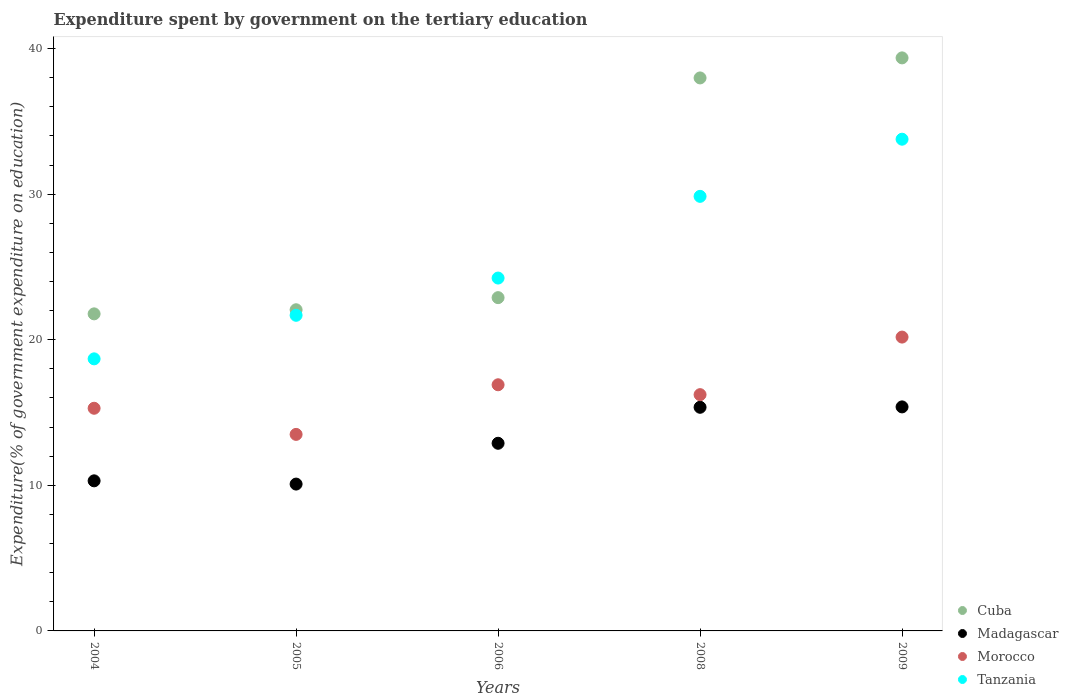How many different coloured dotlines are there?
Offer a very short reply. 4. Is the number of dotlines equal to the number of legend labels?
Ensure brevity in your answer.  Yes. What is the expenditure spent by government on the tertiary education in Morocco in 2005?
Keep it short and to the point. 13.5. Across all years, what is the maximum expenditure spent by government on the tertiary education in Tanzania?
Provide a short and direct response. 33.78. Across all years, what is the minimum expenditure spent by government on the tertiary education in Morocco?
Your response must be concise. 13.5. In which year was the expenditure spent by government on the tertiary education in Madagascar maximum?
Offer a terse response. 2009. What is the total expenditure spent by government on the tertiary education in Madagascar in the graph?
Keep it short and to the point. 64.03. What is the difference between the expenditure spent by government on the tertiary education in Cuba in 2004 and that in 2008?
Provide a short and direct response. -16.21. What is the difference between the expenditure spent by government on the tertiary education in Tanzania in 2004 and the expenditure spent by government on the tertiary education in Morocco in 2009?
Your answer should be very brief. -1.5. What is the average expenditure spent by government on the tertiary education in Madagascar per year?
Make the answer very short. 12.81. In the year 2005, what is the difference between the expenditure spent by government on the tertiary education in Madagascar and expenditure spent by government on the tertiary education in Tanzania?
Your answer should be very brief. -11.59. What is the ratio of the expenditure spent by government on the tertiary education in Tanzania in 2004 to that in 2006?
Provide a succinct answer. 0.77. Is the expenditure spent by government on the tertiary education in Tanzania in 2005 less than that in 2006?
Provide a short and direct response. Yes. Is the difference between the expenditure spent by government on the tertiary education in Madagascar in 2008 and 2009 greater than the difference between the expenditure spent by government on the tertiary education in Tanzania in 2008 and 2009?
Offer a very short reply. Yes. What is the difference between the highest and the second highest expenditure spent by government on the tertiary education in Tanzania?
Provide a short and direct response. 3.93. What is the difference between the highest and the lowest expenditure spent by government on the tertiary education in Tanzania?
Give a very brief answer. 15.09. Is the sum of the expenditure spent by government on the tertiary education in Madagascar in 2005 and 2009 greater than the maximum expenditure spent by government on the tertiary education in Tanzania across all years?
Provide a succinct answer. No. Is it the case that in every year, the sum of the expenditure spent by government on the tertiary education in Morocco and expenditure spent by government on the tertiary education in Tanzania  is greater than the sum of expenditure spent by government on the tertiary education in Cuba and expenditure spent by government on the tertiary education in Madagascar?
Make the answer very short. No. Is the expenditure spent by government on the tertiary education in Madagascar strictly greater than the expenditure spent by government on the tertiary education in Tanzania over the years?
Give a very brief answer. No. Is the expenditure spent by government on the tertiary education in Cuba strictly less than the expenditure spent by government on the tertiary education in Morocco over the years?
Your answer should be very brief. No. How many dotlines are there?
Ensure brevity in your answer.  4. How many years are there in the graph?
Your response must be concise. 5. What is the difference between two consecutive major ticks on the Y-axis?
Keep it short and to the point. 10. Does the graph contain grids?
Ensure brevity in your answer.  No. Where does the legend appear in the graph?
Your response must be concise. Bottom right. How are the legend labels stacked?
Your answer should be compact. Vertical. What is the title of the graph?
Make the answer very short. Expenditure spent by government on the tertiary education. What is the label or title of the Y-axis?
Keep it short and to the point. Expenditure(% of government expenditure on education). What is the Expenditure(% of government expenditure on education) in Cuba in 2004?
Your response must be concise. 21.78. What is the Expenditure(% of government expenditure on education) of Madagascar in 2004?
Your answer should be very brief. 10.31. What is the Expenditure(% of government expenditure on education) in Morocco in 2004?
Offer a very short reply. 15.29. What is the Expenditure(% of government expenditure on education) in Tanzania in 2004?
Ensure brevity in your answer.  18.69. What is the Expenditure(% of government expenditure on education) in Cuba in 2005?
Keep it short and to the point. 22.06. What is the Expenditure(% of government expenditure on education) of Madagascar in 2005?
Your response must be concise. 10.09. What is the Expenditure(% of government expenditure on education) in Morocco in 2005?
Offer a terse response. 13.5. What is the Expenditure(% of government expenditure on education) of Tanzania in 2005?
Your response must be concise. 21.68. What is the Expenditure(% of government expenditure on education) in Cuba in 2006?
Ensure brevity in your answer.  22.89. What is the Expenditure(% of government expenditure on education) of Madagascar in 2006?
Your answer should be very brief. 12.89. What is the Expenditure(% of government expenditure on education) of Morocco in 2006?
Your response must be concise. 16.91. What is the Expenditure(% of government expenditure on education) in Tanzania in 2006?
Give a very brief answer. 24.24. What is the Expenditure(% of government expenditure on education) of Cuba in 2008?
Your response must be concise. 37.98. What is the Expenditure(% of government expenditure on education) of Madagascar in 2008?
Your response must be concise. 15.36. What is the Expenditure(% of government expenditure on education) in Morocco in 2008?
Provide a short and direct response. 16.23. What is the Expenditure(% of government expenditure on education) of Tanzania in 2008?
Provide a short and direct response. 29.85. What is the Expenditure(% of government expenditure on education) in Cuba in 2009?
Your response must be concise. 39.36. What is the Expenditure(% of government expenditure on education) of Madagascar in 2009?
Your answer should be compact. 15.39. What is the Expenditure(% of government expenditure on education) of Morocco in 2009?
Offer a terse response. 20.18. What is the Expenditure(% of government expenditure on education) of Tanzania in 2009?
Make the answer very short. 33.78. Across all years, what is the maximum Expenditure(% of government expenditure on education) of Cuba?
Give a very brief answer. 39.36. Across all years, what is the maximum Expenditure(% of government expenditure on education) of Madagascar?
Provide a short and direct response. 15.39. Across all years, what is the maximum Expenditure(% of government expenditure on education) of Morocco?
Provide a short and direct response. 20.18. Across all years, what is the maximum Expenditure(% of government expenditure on education) in Tanzania?
Give a very brief answer. 33.78. Across all years, what is the minimum Expenditure(% of government expenditure on education) in Cuba?
Provide a succinct answer. 21.78. Across all years, what is the minimum Expenditure(% of government expenditure on education) of Madagascar?
Offer a very short reply. 10.09. Across all years, what is the minimum Expenditure(% of government expenditure on education) in Morocco?
Provide a short and direct response. 13.5. Across all years, what is the minimum Expenditure(% of government expenditure on education) in Tanzania?
Your response must be concise. 18.69. What is the total Expenditure(% of government expenditure on education) of Cuba in the graph?
Provide a succinct answer. 144.08. What is the total Expenditure(% of government expenditure on education) in Madagascar in the graph?
Your response must be concise. 64.03. What is the total Expenditure(% of government expenditure on education) of Morocco in the graph?
Provide a succinct answer. 82.11. What is the total Expenditure(% of government expenditure on education) of Tanzania in the graph?
Keep it short and to the point. 128.23. What is the difference between the Expenditure(% of government expenditure on education) in Cuba in 2004 and that in 2005?
Your answer should be compact. -0.28. What is the difference between the Expenditure(% of government expenditure on education) in Madagascar in 2004 and that in 2005?
Ensure brevity in your answer.  0.22. What is the difference between the Expenditure(% of government expenditure on education) in Morocco in 2004 and that in 2005?
Keep it short and to the point. 1.79. What is the difference between the Expenditure(% of government expenditure on education) of Tanzania in 2004 and that in 2005?
Give a very brief answer. -2.99. What is the difference between the Expenditure(% of government expenditure on education) of Cuba in 2004 and that in 2006?
Your answer should be compact. -1.11. What is the difference between the Expenditure(% of government expenditure on education) in Madagascar in 2004 and that in 2006?
Make the answer very short. -2.58. What is the difference between the Expenditure(% of government expenditure on education) in Morocco in 2004 and that in 2006?
Give a very brief answer. -1.61. What is the difference between the Expenditure(% of government expenditure on education) of Tanzania in 2004 and that in 2006?
Offer a terse response. -5.55. What is the difference between the Expenditure(% of government expenditure on education) of Cuba in 2004 and that in 2008?
Offer a terse response. -16.21. What is the difference between the Expenditure(% of government expenditure on education) of Madagascar in 2004 and that in 2008?
Your response must be concise. -5.05. What is the difference between the Expenditure(% of government expenditure on education) of Morocco in 2004 and that in 2008?
Offer a terse response. -0.94. What is the difference between the Expenditure(% of government expenditure on education) in Tanzania in 2004 and that in 2008?
Offer a terse response. -11.16. What is the difference between the Expenditure(% of government expenditure on education) in Cuba in 2004 and that in 2009?
Ensure brevity in your answer.  -17.58. What is the difference between the Expenditure(% of government expenditure on education) of Madagascar in 2004 and that in 2009?
Ensure brevity in your answer.  -5.08. What is the difference between the Expenditure(% of government expenditure on education) of Morocco in 2004 and that in 2009?
Give a very brief answer. -4.89. What is the difference between the Expenditure(% of government expenditure on education) in Tanzania in 2004 and that in 2009?
Provide a short and direct response. -15.09. What is the difference between the Expenditure(% of government expenditure on education) in Cuba in 2005 and that in 2006?
Offer a very short reply. -0.83. What is the difference between the Expenditure(% of government expenditure on education) in Madagascar in 2005 and that in 2006?
Provide a short and direct response. -2.8. What is the difference between the Expenditure(% of government expenditure on education) in Morocco in 2005 and that in 2006?
Provide a short and direct response. -3.41. What is the difference between the Expenditure(% of government expenditure on education) of Tanzania in 2005 and that in 2006?
Provide a succinct answer. -2.56. What is the difference between the Expenditure(% of government expenditure on education) in Cuba in 2005 and that in 2008?
Your response must be concise. -15.92. What is the difference between the Expenditure(% of government expenditure on education) in Madagascar in 2005 and that in 2008?
Your answer should be compact. -5.28. What is the difference between the Expenditure(% of government expenditure on education) in Morocco in 2005 and that in 2008?
Your answer should be very brief. -2.73. What is the difference between the Expenditure(% of government expenditure on education) of Tanzania in 2005 and that in 2008?
Your response must be concise. -8.17. What is the difference between the Expenditure(% of government expenditure on education) in Cuba in 2005 and that in 2009?
Provide a short and direct response. -17.3. What is the difference between the Expenditure(% of government expenditure on education) of Madagascar in 2005 and that in 2009?
Offer a very short reply. -5.3. What is the difference between the Expenditure(% of government expenditure on education) of Morocco in 2005 and that in 2009?
Provide a succinct answer. -6.68. What is the difference between the Expenditure(% of government expenditure on education) in Tanzania in 2005 and that in 2009?
Your answer should be compact. -12.1. What is the difference between the Expenditure(% of government expenditure on education) in Cuba in 2006 and that in 2008?
Your answer should be compact. -15.09. What is the difference between the Expenditure(% of government expenditure on education) of Madagascar in 2006 and that in 2008?
Your answer should be compact. -2.47. What is the difference between the Expenditure(% of government expenditure on education) of Morocco in 2006 and that in 2008?
Provide a succinct answer. 0.68. What is the difference between the Expenditure(% of government expenditure on education) of Tanzania in 2006 and that in 2008?
Your answer should be very brief. -5.61. What is the difference between the Expenditure(% of government expenditure on education) of Cuba in 2006 and that in 2009?
Ensure brevity in your answer.  -16.47. What is the difference between the Expenditure(% of government expenditure on education) in Madagascar in 2006 and that in 2009?
Ensure brevity in your answer.  -2.5. What is the difference between the Expenditure(% of government expenditure on education) of Morocco in 2006 and that in 2009?
Ensure brevity in your answer.  -3.28. What is the difference between the Expenditure(% of government expenditure on education) of Tanzania in 2006 and that in 2009?
Offer a very short reply. -9.54. What is the difference between the Expenditure(% of government expenditure on education) of Cuba in 2008 and that in 2009?
Keep it short and to the point. -1.38. What is the difference between the Expenditure(% of government expenditure on education) in Madagascar in 2008 and that in 2009?
Give a very brief answer. -0.03. What is the difference between the Expenditure(% of government expenditure on education) of Morocco in 2008 and that in 2009?
Make the answer very short. -3.95. What is the difference between the Expenditure(% of government expenditure on education) in Tanzania in 2008 and that in 2009?
Offer a very short reply. -3.93. What is the difference between the Expenditure(% of government expenditure on education) of Cuba in 2004 and the Expenditure(% of government expenditure on education) of Madagascar in 2005?
Your answer should be very brief. 11.69. What is the difference between the Expenditure(% of government expenditure on education) in Cuba in 2004 and the Expenditure(% of government expenditure on education) in Morocco in 2005?
Your answer should be very brief. 8.28. What is the difference between the Expenditure(% of government expenditure on education) of Cuba in 2004 and the Expenditure(% of government expenditure on education) of Tanzania in 2005?
Your answer should be very brief. 0.1. What is the difference between the Expenditure(% of government expenditure on education) in Madagascar in 2004 and the Expenditure(% of government expenditure on education) in Morocco in 2005?
Provide a short and direct response. -3.19. What is the difference between the Expenditure(% of government expenditure on education) in Madagascar in 2004 and the Expenditure(% of government expenditure on education) in Tanzania in 2005?
Provide a succinct answer. -11.37. What is the difference between the Expenditure(% of government expenditure on education) in Morocco in 2004 and the Expenditure(% of government expenditure on education) in Tanzania in 2005?
Your response must be concise. -6.39. What is the difference between the Expenditure(% of government expenditure on education) of Cuba in 2004 and the Expenditure(% of government expenditure on education) of Madagascar in 2006?
Offer a very short reply. 8.89. What is the difference between the Expenditure(% of government expenditure on education) in Cuba in 2004 and the Expenditure(% of government expenditure on education) in Morocco in 2006?
Provide a succinct answer. 4.87. What is the difference between the Expenditure(% of government expenditure on education) of Cuba in 2004 and the Expenditure(% of government expenditure on education) of Tanzania in 2006?
Keep it short and to the point. -2.46. What is the difference between the Expenditure(% of government expenditure on education) of Madagascar in 2004 and the Expenditure(% of government expenditure on education) of Morocco in 2006?
Your answer should be compact. -6.6. What is the difference between the Expenditure(% of government expenditure on education) in Madagascar in 2004 and the Expenditure(% of government expenditure on education) in Tanzania in 2006?
Offer a very short reply. -13.93. What is the difference between the Expenditure(% of government expenditure on education) of Morocco in 2004 and the Expenditure(% of government expenditure on education) of Tanzania in 2006?
Keep it short and to the point. -8.94. What is the difference between the Expenditure(% of government expenditure on education) in Cuba in 2004 and the Expenditure(% of government expenditure on education) in Madagascar in 2008?
Provide a succinct answer. 6.42. What is the difference between the Expenditure(% of government expenditure on education) in Cuba in 2004 and the Expenditure(% of government expenditure on education) in Morocco in 2008?
Give a very brief answer. 5.55. What is the difference between the Expenditure(% of government expenditure on education) in Cuba in 2004 and the Expenditure(% of government expenditure on education) in Tanzania in 2008?
Your answer should be very brief. -8.07. What is the difference between the Expenditure(% of government expenditure on education) of Madagascar in 2004 and the Expenditure(% of government expenditure on education) of Morocco in 2008?
Offer a very short reply. -5.92. What is the difference between the Expenditure(% of government expenditure on education) of Madagascar in 2004 and the Expenditure(% of government expenditure on education) of Tanzania in 2008?
Your answer should be very brief. -19.54. What is the difference between the Expenditure(% of government expenditure on education) in Morocco in 2004 and the Expenditure(% of government expenditure on education) in Tanzania in 2008?
Your answer should be compact. -14.56. What is the difference between the Expenditure(% of government expenditure on education) of Cuba in 2004 and the Expenditure(% of government expenditure on education) of Madagascar in 2009?
Your answer should be very brief. 6.39. What is the difference between the Expenditure(% of government expenditure on education) of Cuba in 2004 and the Expenditure(% of government expenditure on education) of Morocco in 2009?
Offer a very short reply. 1.6. What is the difference between the Expenditure(% of government expenditure on education) of Cuba in 2004 and the Expenditure(% of government expenditure on education) of Tanzania in 2009?
Make the answer very short. -12. What is the difference between the Expenditure(% of government expenditure on education) in Madagascar in 2004 and the Expenditure(% of government expenditure on education) in Morocco in 2009?
Your answer should be compact. -9.87. What is the difference between the Expenditure(% of government expenditure on education) of Madagascar in 2004 and the Expenditure(% of government expenditure on education) of Tanzania in 2009?
Offer a very short reply. -23.47. What is the difference between the Expenditure(% of government expenditure on education) in Morocco in 2004 and the Expenditure(% of government expenditure on education) in Tanzania in 2009?
Your answer should be compact. -18.48. What is the difference between the Expenditure(% of government expenditure on education) in Cuba in 2005 and the Expenditure(% of government expenditure on education) in Madagascar in 2006?
Provide a succinct answer. 9.17. What is the difference between the Expenditure(% of government expenditure on education) in Cuba in 2005 and the Expenditure(% of government expenditure on education) in Morocco in 2006?
Your answer should be compact. 5.15. What is the difference between the Expenditure(% of government expenditure on education) of Cuba in 2005 and the Expenditure(% of government expenditure on education) of Tanzania in 2006?
Ensure brevity in your answer.  -2.18. What is the difference between the Expenditure(% of government expenditure on education) in Madagascar in 2005 and the Expenditure(% of government expenditure on education) in Morocco in 2006?
Provide a short and direct response. -6.82. What is the difference between the Expenditure(% of government expenditure on education) of Madagascar in 2005 and the Expenditure(% of government expenditure on education) of Tanzania in 2006?
Keep it short and to the point. -14.15. What is the difference between the Expenditure(% of government expenditure on education) of Morocco in 2005 and the Expenditure(% of government expenditure on education) of Tanzania in 2006?
Your answer should be very brief. -10.74. What is the difference between the Expenditure(% of government expenditure on education) in Cuba in 2005 and the Expenditure(% of government expenditure on education) in Madagascar in 2008?
Your answer should be very brief. 6.7. What is the difference between the Expenditure(% of government expenditure on education) in Cuba in 2005 and the Expenditure(% of government expenditure on education) in Morocco in 2008?
Make the answer very short. 5.83. What is the difference between the Expenditure(% of government expenditure on education) in Cuba in 2005 and the Expenditure(% of government expenditure on education) in Tanzania in 2008?
Offer a very short reply. -7.79. What is the difference between the Expenditure(% of government expenditure on education) in Madagascar in 2005 and the Expenditure(% of government expenditure on education) in Morocco in 2008?
Your answer should be very brief. -6.14. What is the difference between the Expenditure(% of government expenditure on education) in Madagascar in 2005 and the Expenditure(% of government expenditure on education) in Tanzania in 2008?
Offer a terse response. -19.76. What is the difference between the Expenditure(% of government expenditure on education) in Morocco in 2005 and the Expenditure(% of government expenditure on education) in Tanzania in 2008?
Keep it short and to the point. -16.35. What is the difference between the Expenditure(% of government expenditure on education) in Cuba in 2005 and the Expenditure(% of government expenditure on education) in Madagascar in 2009?
Offer a very short reply. 6.67. What is the difference between the Expenditure(% of government expenditure on education) in Cuba in 2005 and the Expenditure(% of government expenditure on education) in Morocco in 2009?
Offer a very short reply. 1.88. What is the difference between the Expenditure(% of government expenditure on education) of Cuba in 2005 and the Expenditure(% of government expenditure on education) of Tanzania in 2009?
Give a very brief answer. -11.72. What is the difference between the Expenditure(% of government expenditure on education) of Madagascar in 2005 and the Expenditure(% of government expenditure on education) of Morocco in 2009?
Make the answer very short. -10.1. What is the difference between the Expenditure(% of government expenditure on education) of Madagascar in 2005 and the Expenditure(% of government expenditure on education) of Tanzania in 2009?
Offer a very short reply. -23.69. What is the difference between the Expenditure(% of government expenditure on education) in Morocco in 2005 and the Expenditure(% of government expenditure on education) in Tanzania in 2009?
Offer a terse response. -20.28. What is the difference between the Expenditure(% of government expenditure on education) in Cuba in 2006 and the Expenditure(% of government expenditure on education) in Madagascar in 2008?
Provide a short and direct response. 7.53. What is the difference between the Expenditure(% of government expenditure on education) of Cuba in 2006 and the Expenditure(% of government expenditure on education) of Morocco in 2008?
Your answer should be very brief. 6.66. What is the difference between the Expenditure(% of government expenditure on education) in Cuba in 2006 and the Expenditure(% of government expenditure on education) in Tanzania in 2008?
Provide a succinct answer. -6.96. What is the difference between the Expenditure(% of government expenditure on education) of Madagascar in 2006 and the Expenditure(% of government expenditure on education) of Morocco in 2008?
Your answer should be compact. -3.34. What is the difference between the Expenditure(% of government expenditure on education) in Madagascar in 2006 and the Expenditure(% of government expenditure on education) in Tanzania in 2008?
Ensure brevity in your answer.  -16.96. What is the difference between the Expenditure(% of government expenditure on education) in Morocco in 2006 and the Expenditure(% of government expenditure on education) in Tanzania in 2008?
Make the answer very short. -12.94. What is the difference between the Expenditure(% of government expenditure on education) in Cuba in 2006 and the Expenditure(% of government expenditure on education) in Madagascar in 2009?
Your response must be concise. 7.5. What is the difference between the Expenditure(% of government expenditure on education) of Cuba in 2006 and the Expenditure(% of government expenditure on education) of Morocco in 2009?
Keep it short and to the point. 2.71. What is the difference between the Expenditure(% of government expenditure on education) in Cuba in 2006 and the Expenditure(% of government expenditure on education) in Tanzania in 2009?
Your answer should be very brief. -10.88. What is the difference between the Expenditure(% of government expenditure on education) in Madagascar in 2006 and the Expenditure(% of government expenditure on education) in Morocco in 2009?
Provide a succinct answer. -7.29. What is the difference between the Expenditure(% of government expenditure on education) of Madagascar in 2006 and the Expenditure(% of government expenditure on education) of Tanzania in 2009?
Your answer should be very brief. -20.89. What is the difference between the Expenditure(% of government expenditure on education) in Morocco in 2006 and the Expenditure(% of government expenditure on education) in Tanzania in 2009?
Offer a terse response. -16.87. What is the difference between the Expenditure(% of government expenditure on education) of Cuba in 2008 and the Expenditure(% of government expenditure on education) of Madagascar in 2009?
Provide a succinct answer. 22.6. What is the difference between the Expenditure(% of government expenditure on education) of Cuba in 2008 and the Expenditure(% of government expenditure on education) of Morocco in 2009?
Provide a succinct answer. 17.8. What is the difference between the Expenditure(% of government expenditure on education) in Cuba in 2008 and the Expenditure(% of government expenditure on education) in Tanzania in 2009?
Your response must be concise. 4.21. What is the difference between the Expenditure(% of government expenditure on education) of Madagascar in 2008 and the Expenditure(% of government expenditure on education) of Morocco in 2009?
Your answer should be compact. -4.82. What is the difference between the Expenditure(% of government expenditure on education) of Madagascar in 2008 and the Expenditure(% of government expenditure on education) of Tanzania in 2009?
Offer a terse response. -18.41. What is the difference between the Expenditure(% of government expenditure on education) of Morocco in 2008 and the Expenditure(% of government expenditure on education) of Tanzania in 2009?
Provide a short and direct response. -17.55. What is the average Expenditure(% of government expenditure on education) in Cuba per year?
Offer a very short reply. 28.82. What is the average Expenditure(% of government expenditure on education) in Madagascar per year?
Ensure brevity in your answer.  12.81. What is the average Expenditure(% of government expenditure on education) in Morocco per year?
Your answer should be compact. 16.42. What is the average Expenditure(% of government expenditure on education) of Tanzania per year?
Keep it short and to the point. 25.65. In the year 2004, what is the difference between the Expenditure(% of government expenditure on education) in Cuba and Expenditure(% of government expenditure on education) in Madagascar?
Your answer should be compact. 11.47. In the year 2004, what is the difference between the Expenditure(% of government expenditure on education) of Cuba and Expenditure(% of government expenditure on education) of Morocco?
Your response must be concise. 6.48. In the year 2004, what is the difference between the Expenditure(% of government expenditure on education) of Cuba and Expenditure(% of government expenditure on education) of Tanzania?
Make the answer very short. 3.09. In the year 2004, what is the difference between the Expenditure(% of government expenditure on education) in Madagascar and Expenditure(% of government expenditure on education) in Morocco?
Your answer should be compact. -4.99. In the year 2004, what is the difference between the Expenditure(% of government expenditure on education) of Madagascar and Expenditure(% of government expenditure on education) of Tanzania?
Provide a succinct answer. -8.38. In the year 2004, what is the difference between the Expenditure(% of government expenditure on education) of Morocco and Expenditure(% of government expenditure on education) of Tanzania?
Give a very brief answer. -3.39. In the year 2005, what is the difference between the Expenditure(% of government expenditure on education) in Cuba and Expenditure(% of government expenditure on education) in Madagascar?
Give a very brief answer. 11.97. In the year 2005, what is the difference between the Expenditure(% of government expenditure on education) of Cuba and Expenditure(% of government expenditure on education) of Morocco?
Give a very brief answer. 8.56. In the year 2005, what is the difference between the Expenditure(% of government expenditure on education) of Cuba and Expenditure(% of government expenditure on education) of Tanzania?
Offer a very short reply. 0.38. In the year 2005, what is the difference between the Expenditure(% of government expenditure on education) of Madagascar and Expenditure(% of government expenditure on education) of Morocco?
Offer a very short reply. -3.41. In the year 2005, what is the difference between the Expenditure(% of government expenditure on education) in Madagascar and Expenditure(% of government expenditure on education) in Tanzania?
Provide a short and direct response. -11.59. In the year 2005, what is the difference between the Expenditure(% of government expenditure on education) of Morocco and Expenditure(% of government expenditure on education) of Tanzania?
Your answer should be compact. -8.18. In the year 2006, what is the difference between the Expenditure(% of government expenditure on education) of Cuba and Expenditure(% of government expenditure on education) of Madagascar?
Offer a terse response. 10. In the year 2006, what is the difference between the Expenditure(% of government expenditure on education) of Cuba and Expenditure(% of government expenditure on education) of Morocco?
Offer a terse response. 5.98. In the year 2006, what is the difference between the Expenditure(% of government expenditure on education) in Cuba and Expenditure(% of government expenditure on education) in Tanzania?
Offer a very short reply. -1.34. In the year 2006, what is the difference between the Expenditure(% of government expenditure on education) in Madagascar and Expenditure(% of government expenditure on education) in Morocco?
Your answer should be very brief. -4.02. In the year 2006, what is the difference between the Expenditure(% of government expenditure on education) in Madagascar and Expenditure(% of government expenditure on education) in Tanzania?
Your answer should be very brief. -11.35. In the year 2006, what is the difference between the Expenditure(% of government expenditure on education) of Morocco and Expenditure(% of government expenditure on education) of Tanzania?
Give a very brief answer. -7.33. In the year 2008, what is the difference between the Expenditure(% of government expenditure on education) of Cuba and Expenditure(% of government expenditure on education) of Madagascar?
Offer a very short reply. 22.62. In the year 2008, what is the difference between the Expenditure(% of government expenditure on education) of Cuba and Expenditure(% of government expenditure on education) of Morocco?
Provide a short and direct response. 21.75. In the year 2008, what is the difference between the Expenditure(% of government expenditure on education) in Cuba and Expenditure(% of government expenditure on education) in Tanzania?
Give a very brief answer. 8.13. In the year 2008, what is the difference between the Expenditure(% of government expenditure on education) in Madagascar and Expenditure(% of government expenditure on education) in Morocco?
Provide a short and direct response. -0.87. In the year 2008, what is the difference between the Expenditure(% of government expenditure on education) in Madagascar and Expenditure(% of government expenditure on education) in Tanzania?
Make the answer very short. -14.49. In the year 2008, what is the difference between the Expenditure(% of government expenditure on education) in Morocco and Expenditure(% of government expenditure on education) in Tanzania?
Give a very brief answer. -13.62. In the year 2009, what is the difference between the Expenditure(% of government expenditure on education) of Cuba and Expenditure(% of government expenditure on education) of Madagascar?
Provide a short and direct response. 23.97. In the year 2009, what is the difference between the Expenditure(% of government expenditure on education) of Cuba and Expenditure(% of government expenditure on education) of Morocco?
Provide a succinct answer. 19.18. In the year 2009, what is the difference between the Expenditure(% of government expenditure on education) in Cuba and Expenditure(% of government expenditure on education) in Tanzania?
Give a very brief answer. 5.59. In the year 2009, what is the difference between the Expenditure(% of government expenditure on education) of Madagascar and Expenditure(% of government expenditure on education) of Morocco?
Your answer should be compact. -4.8. In the year 2009, what is the difference between the Expenditure(% of government expenditure on education) of Madagascar and Expenditure(% of government expenditure on education) of Tanzania?
Your answer should be compact. -18.39. In the year 2009, what is the difference between the Expenditure(% of government expenditure on education) in Morocco and Expenditure(% of government expenditure on education) in Tanzania?
Offer a very short reply. -13.59. What is the ratio of the Expenditure(% of government expenditure on education) in Cuba in 2004 to that in 2005?
Your response must be concise. 0.99. What is the ratio of the Expenditure(% of government expenditure on education) in Madagascar in 2004 to that in 2005?
Offer a terse response. 1.02. What is the ratio of the Expenditure(% of government expenditure on education) of Morocco in 2004 to that in 2005?
Your answer should be very brief. 1.13. What is the ratio of the Expenditure(% of government expenditure on education) in Tanzania in 2004 to that in 2005?
Your answer should be compact. 0.86. What is the ratio of the Expenditure(% of government expenditure on education) in Cuba in 2004 to that in 2006?
Ensure brevity in your answer.  0.95. What is the ratio of the Expenditure(% of government expenditure on education) of Madagascar in 2004 to that in 2006?
Give a very brief answer. 0.8. What is the ratio of the Expenditure(% of government expenditure on education) of Morocco in 2004 to that in 2006?
Your response must be concise. 0.9. What is the ratio of the Expenditure(% of government expenditure on education) of Tanzania in 2004 to that in 2006?
Provide a short and direct response. 0.77. What is the ratio of the Expenditure(% of government expenditure on education) in Cuba in 2004 to that in 2008?
Your response must be concise. 0.57. What is the ratio of the Expenditure(% of government expenditure on education) of Madagascar in 2004 to that in 2008?
Provide a succinct answer. 0.67. What is the ratio of the Expenditure(% of government expenditure on education) of Morocco in 2004 to that in 2008?
Your answer should be compact. 0.94. What is the ratio of the Expenditure(% of government expenditure on education) of Tanzania in 2004 to that in 2008?
Keep it short and to the point. 0.63. What is the ratio of the Expenditure(% of government expenditure on education) of Cuba in 2004 to that in 2009?
Your answer should be very brief. 0.55. What is the ratio of the Expenditure(% of government expenditure on education) of Madagascar in 2004 to that in 2009?
Give a very brief answer. 0.67. What is the ratio of the Expenditure(% of government expenditure on education) of Morocco in 2004 to that in 2009?
Give a very brief answer. 0.76. What is the ratio of the Expenditure(% of government expenditure on education) of Tanzania in 2004 to that in 2009?
Your response must be concise. 0.55. What is the ratio of the Expenditure(% of government expenditure on education) in Cuba in 2005 to that in 2006?
Provide a succinct answer. 0.96. What is the ratio of the Expenditure(% of government expenditure on education) of Madagascar in 2005 to that in 2006?
Keep it short and to the point. 0.78. What is the ratio of the Expenditure(% of government expenditure on education) in Morocco in 2005 to that in 2006?
Provide a succinct answer. 0.8. What is the ratio of the Expenditure(% of government expenditure on education) in Tanzania in 2005 to that in 2006?
Your response must be concise. 0.89. What is the ratio of the Expenditure(% of government expenditure on education) of Cuba in 2005 to that in 2008?
Ensure brevity in your answer.  0.58. What is the ratio of the Expenditure(% of government expenditure on education) in Madagascar in 2005 to that in 2008?
Make the answer very short. 0.66. What is the ratio of the Expenditure(% of government expenditure on education) in Morocco in 2005 to that in 2008?
Provide a succinct answer. 0.83. What is the ratio of the Expenditure(% of government expenditure on education) in Tanzania in 2005 to that in 2008?
Make the answer very short. 0.73. What is the ratio of the Expenditure(% of government expenditure on education) of Cuba in 2005 to that in 2009?
Your answer should be compact. 0.56. What is the ratio of the Expenditure(% of government expenditure on education) of Madagascar in 2005 to that in 2009?
Your response must be concise. 0.66. What is the ratio of the Expenditure(% of government expenditure on education) of Morocco in 2005 to that in 2009?
Your answer should be compact. 0.67. What is the ratio of the Expenditure(% of government expenditure on education) of Tanzania in 2005 to that in 2009?
Provide a succinct answer. 0.64. What is the ratio of the Expenditure(% of government expenditure on education) in Cuba in 2006 to that in 2008?
Keep it short and to the point. 0.6. What is the ratio of the Expenditure(% of government expenditure on education) of Madagascar in 2006 to that in 2008?
Provide a short and direct response. 0.84. What is the ratio of the Expenditure(% of government expenditure on education) of Morocco in 2006 to that in 2008?
Your response must be concise. 1.04. What is the ratio of the Expenditure(% of government expenditure on education) of Tanzania in 2006 to that in 2008?
Your answer should be compact. 0.81. What is the ratio of the Expenditure(% of government expenditure on education) in Cuba in 2006 to that in 2009?
Provide a short and direct response. 0.58. What is the ratio of the Expenditure(% of government expenditure on education) of Madagascar in 2006 to that in 2009?
Ensure brevity in your answer.  0.84. What is the ratio of the Expenditure(% of government expenditure on education) in Morocco in 2006 to that in 2009?
Your response must be concise. 0.84. What is the ratio of the Expenditure(% of government expenditure on education) of Tanzania in 2006 to that in 2009?
Give a very brief answer. 0.72. What is the ratio of the Expenditure(% of government expenditure on education) in Cuba in 2008 to that in 2009?
Offer a very short reply. 0.96. What is the ratio of the Expenditure(% of government expenditure on education) in Morocco in 2008 to that in 2009?
Provide a succinct answer. 0.8. What is the ratio of the Expenditure(% of government expenditure on education) of Tanzania in 2008 to that in 2009?
Keep it short and to the point. 0.88. What is the difference between the highest and the second highest Expenditure(% of government expenditure on education) in Cuba?
Your response must be concise. 1.38. What is the difference between the highest and the second highest Expenditure(% of government expenditure on education) of Madagascar?
Offer a terse response. 0.03. What is the difference between the highest and the second highest Expenditure(% of government expenditure on education) of Morocco?
Make the answer very short. 3.28. What is the difference between the highest and the second highest Expenditure(% of government expenditure on education) in Tanzania?
Offer a very short reply. 3.93. What is the difference between the highest and the lowest Expenditure(% of government expenditure on education) of Cuba?
Provide a short and direct response. 17.58. What is the difference between the highest and the lowest Expenditure(% of government expenditure on education) in Madagascar?
Your answer should be compact. 5.3. What is the difference between the highest and the lowest Expenditure(% of government expenditure on education) in Morocco?
Offer a terse response. 6.68. What is the difference between the highest and the lowest Expenditure(% of government expenditure on education) in Tanzania?
Provide a short and direct response. 15.09. 